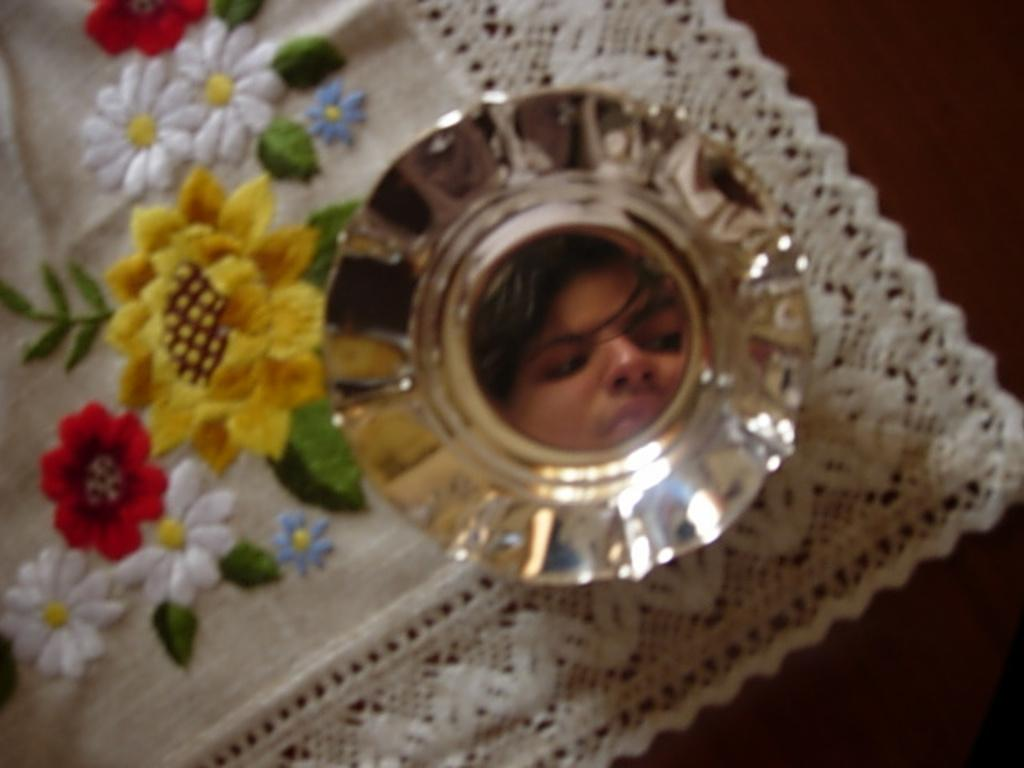What is in the bowl that is visible in the image? The bowl contains a face of a person. Where is the bowl located in the image? The bowl is on a mat. What can be seen on the mat in the image? The mat has designs of flowers and leaves. What is the mat placed on in the image? The mat is on a surface. How many grapes are present on the person's face in the image? There are no grapes present on the person's face in the image. What type of stone is used to create the designs on the mat? The image does not provide information about the material used to create the designs on the mat. 